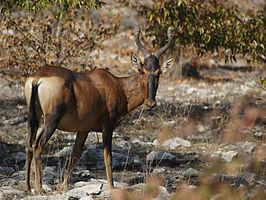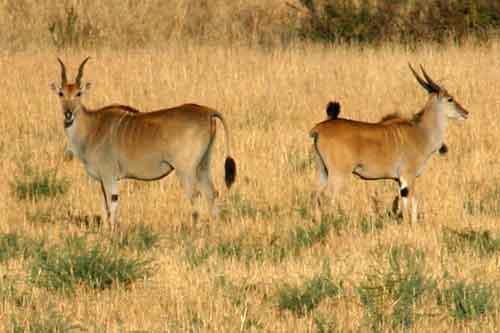The first image is the image on the left, the second image is the image on the right. Considering the images on both sides, is "there are 3 antelope in the image pair" valid? Answer yes or no. Yes. 